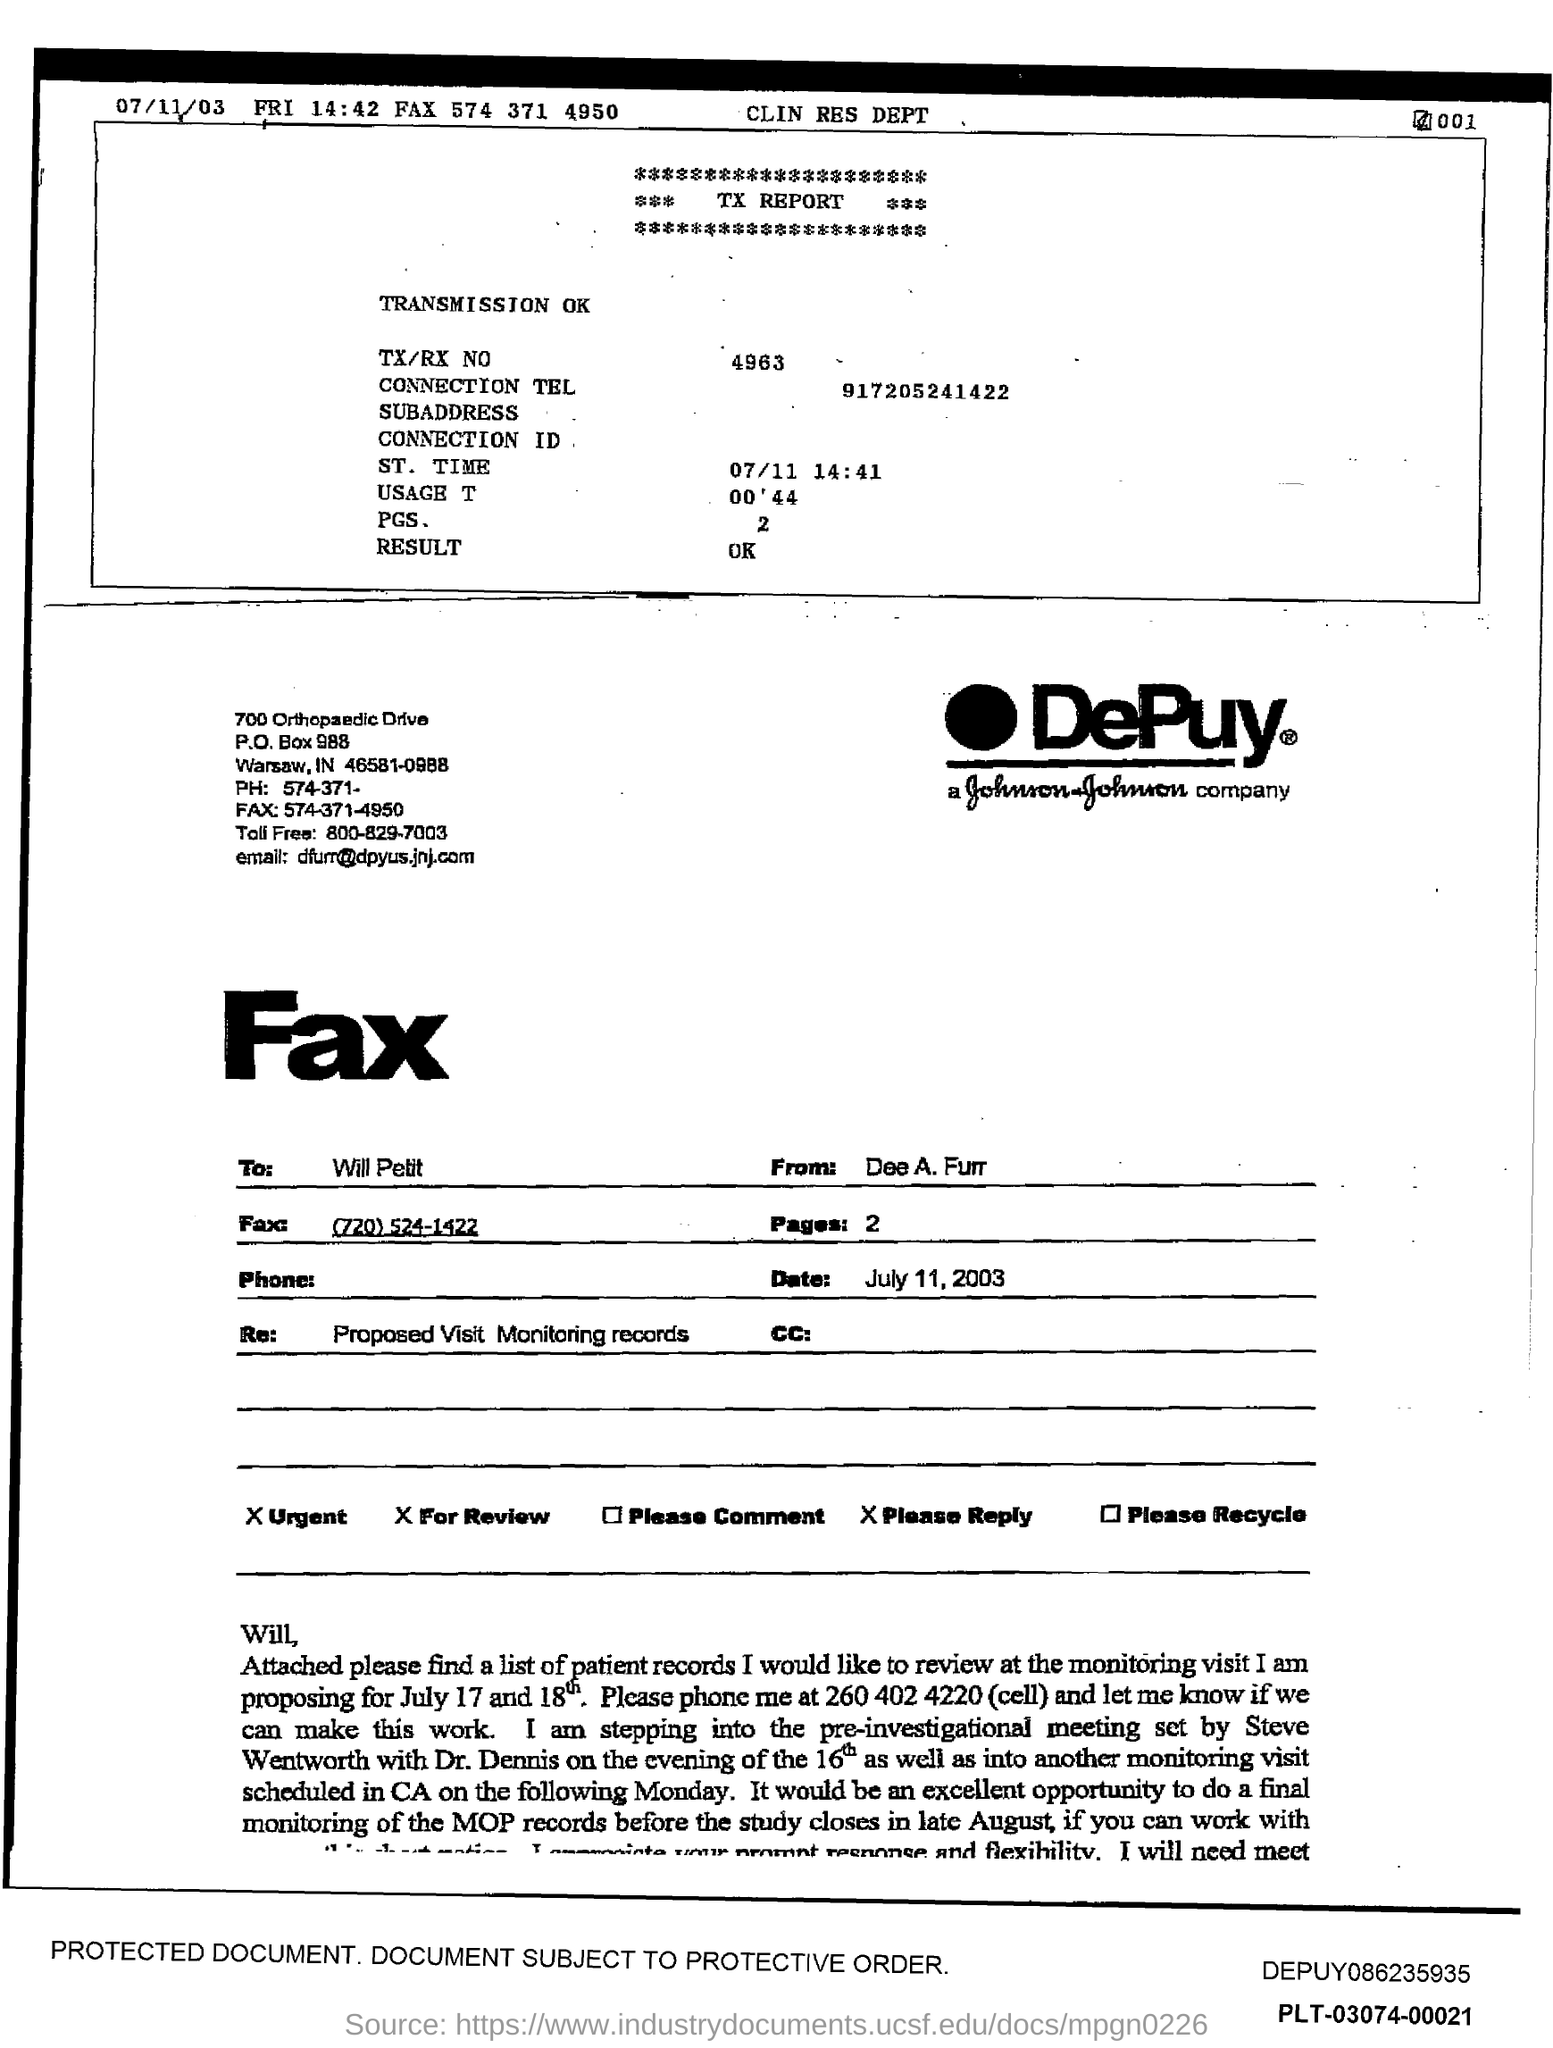Specify some key components in this picture. The toll-free number is 800-829-7003. The email address is [dfurr@dpyus.jnj.com](mailto:dfurr@dpyus.jnj.com). The TX/RX number is 4963. The document contains a PO Box number that is 988... 